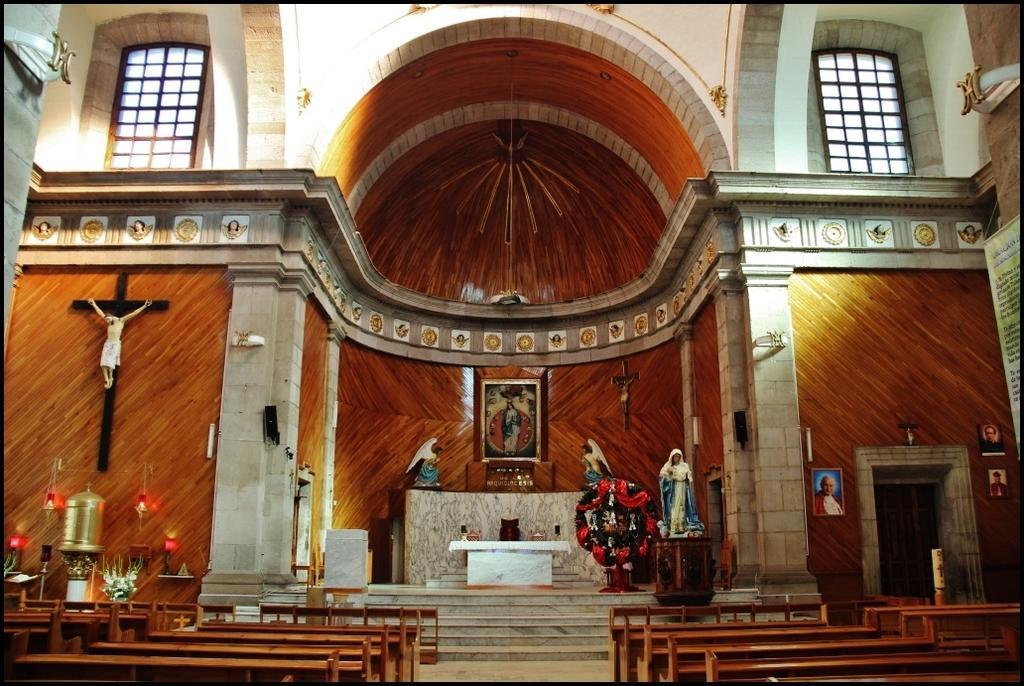Please provide a concise description of this image. In this picture we can see the inside view of the church. In the front we can see the photo frame. Above there is a big dome and glass window. In the front bottom side there are some wooden benches. 